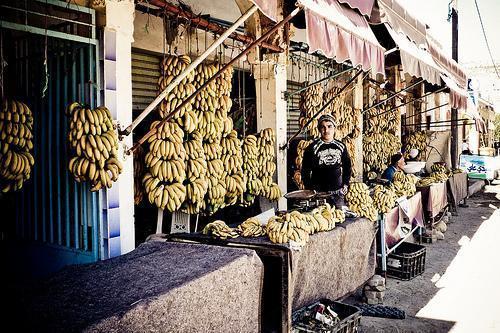How many people in picture?
Give a very brief answer. 3. 